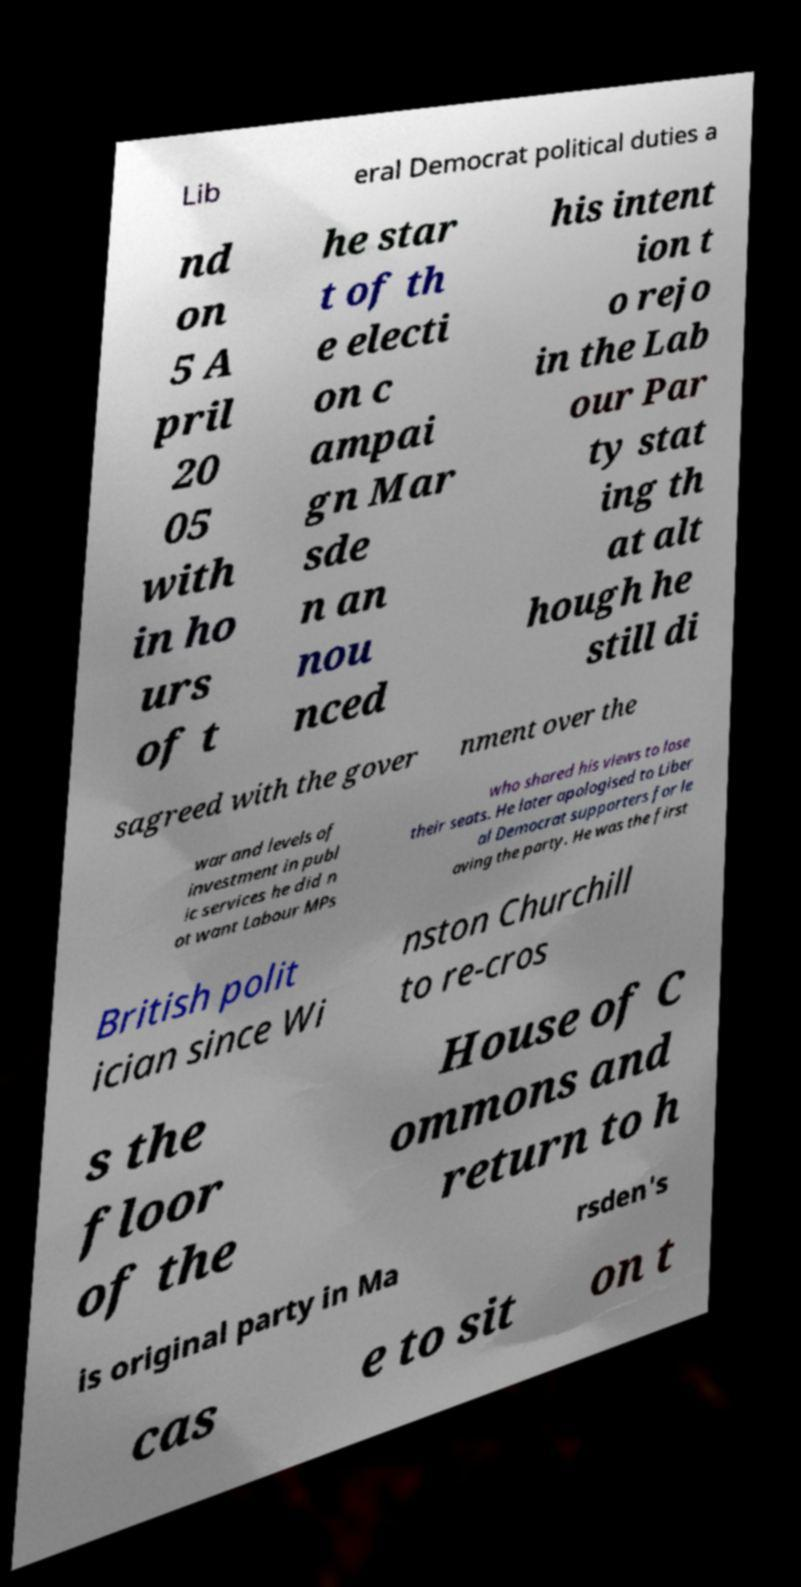I need the written content from this picture converted into text. Can you do that? Lib eral Democrat political duties a nd on 5 A pril 20 05 with in ho urs of t he star t of th e electi on c ampai gn Mar sde n an nou nced his intent ion t o rejo in the Lab our Par ty stat ing th at alt hough he still di sagreed with the gover nment over the war and levels of investment in publ ic services he did n ot want Labour MPs who shared his views to lose their seats. He later apologised to Liber al Democrat supporters for le aving the party. He was the first British polit ician since Wi nston Churchill to re-cros s the floor of the House of C ommons and return to h is original party in Ma rsden's cas e to sit on t 